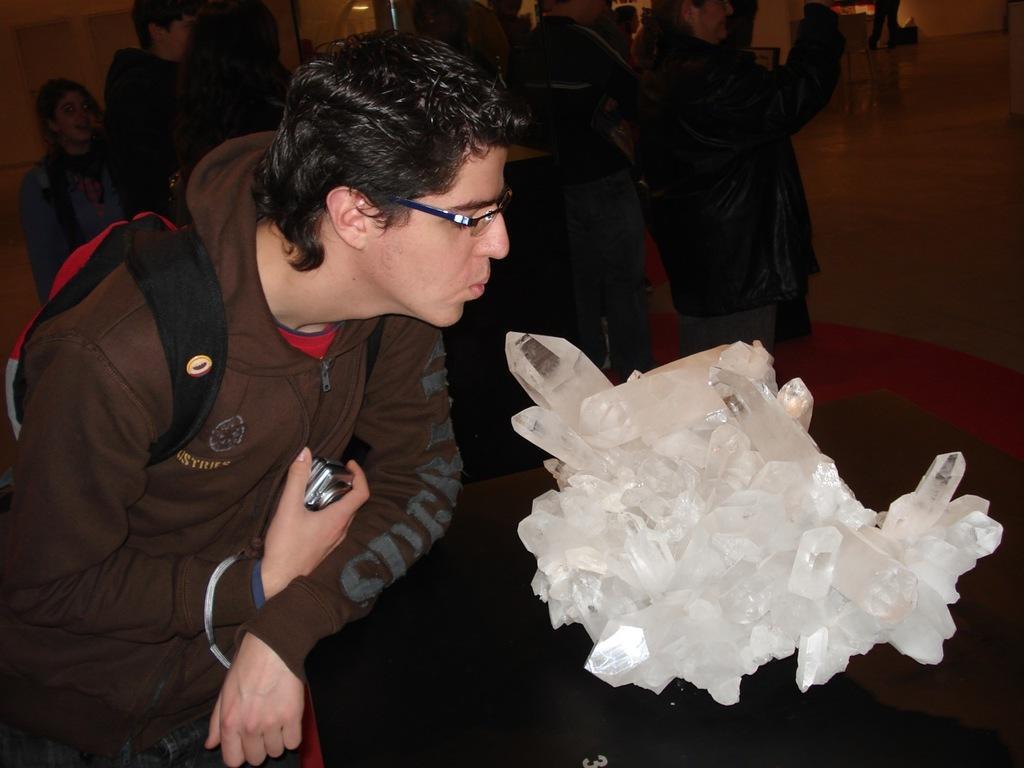How would you summarize this image in a sentence or two? In this image we can see a man is standing and carrying a bag on his shoulders and holding a camera in his hand. There are crystal objects on a platform. In the background there are few persons standing on the floor, wall, light and objects. 